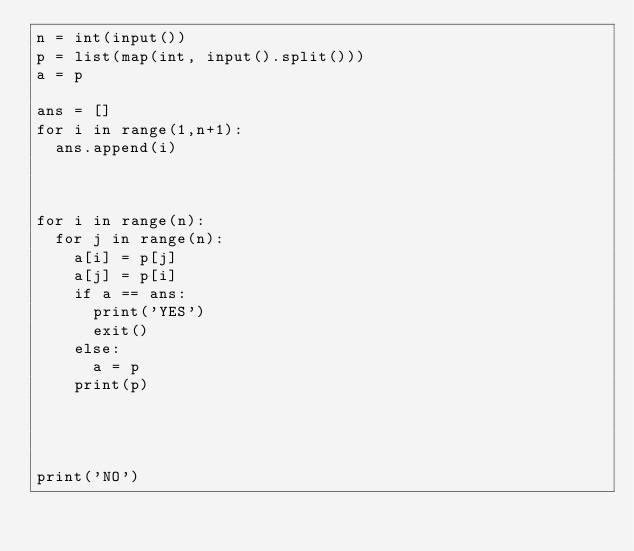<code> <loc_0><loc_0><loc_500><loc_500><_Python_>n = int(input())
p = list(map(int, input().split()))
a = p

ans = []
for i in range(1,n+1):
  ans.append(i)

  

for i in range(n):
  for j in range(n):
    a[i] = p[j]
    a[j] = p[i]
    if a == ans:
      print('YES')
      exit()
    else:
      a = p
    print(p)    
      
      
      
    
print('NO')</code> 